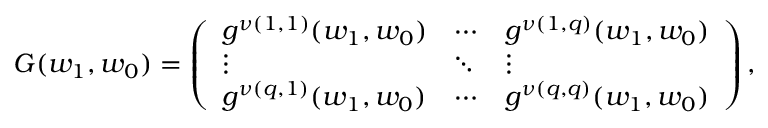<formula> <loc_0><loc_0><loc_500><loc_500>G ( w _ { 1 } , w _ { 0 } ) = \left ( \begin{array} { l l l } { g ^ { \nu ( 1 , 1 ) } ( w _ { 1 } , w _ { 0 } ) } & { \cdots } & { g ^ { \nu ( 1 , q ) } ( w _ { 1 } , w _ { 0 } ) } \\ { \vdots } & { \ddots } & { \vdots } \\ { g ^ { \nu ( q , 1 ) } ( w _ { 1 } , w _ { 0 } ) } & { \cdots } & { g ^ { \nu ( q , q ) } ( w _ { 1 } , w _ { 0 } ) } \end{array} \right ) ,</formula> 